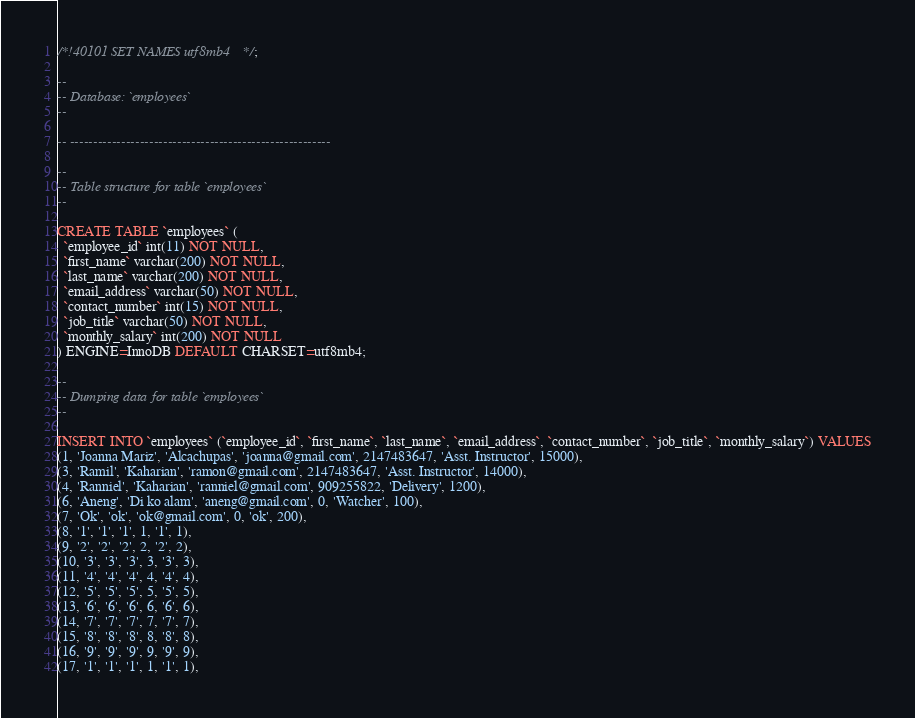Convert code to text. <code><loc_0><loc_0><loc_500><loc_500><_SQL_>/*!40101 SET NAMES utf8mb4 */;

--
-- Database: `employees`
--

-- --------------------------------------------------------

--
-- Table structure for table `employees`
--

CREATE TABLE `employees` (
  `employee_id` int(11) NOT NULL,
  `first_name` varchar(200) NOT NULL,
  `last_name` varchar(200) NOT NULL,
  `email_address` varchar(50) NOT NULL,
  `contact_number` int(15) NOT NULL,
  `job_title` varchar(50) NOT NULL,
  `monthly_salary` int(200) NOT NULL
) ENGINE=InnoDB DEFAULT CHARSET=utf8mb4;

--
-- Dumping data for table `employees`
--

INSERT INTO `employees` (`employee_id`, `first_name`, `last_name`, `email_address`, `contact_number`, `job_title`, `monthly_salary`) VALUES
(1, 'Joanna Mariz', 'Alcachupas', 'joanna@gmail.com', 2147483647, 'Asst. Instructor', 15000),
(3, 'Ramil', 'Kaharian', 'ramon@gmail.com', 2147483647, 'Asst. Instructor', 14000),
(4, 'Ranniel', 'Kaharian', 'ranniel@gmail.com', 909255822, 'Delivery', 1200),
(6, 'Aneng', 'Di ko alam', 'aneng@gmail.com', 0, 'Watcher', 100),
(7, 'Ok', 'ok', 'ok@gmail.com', 0, 'ok', 200),
(8, '1', '1', '1', 1, '1', 1),
(9, '2', '2', '2', 2, '2', 2),
(10, '3', '3', '3', 3, '3', 3),
(11, '4', '4', '4', 4, '4', 4),
(12, '5', '5', '5', 5, '5', 5),
(13, '6', '6', '6', 6, '6', 6),
(14, '7', '7', '7', 7, '7', 7),
(15, '8', '8', '8', 8, '8', 8),
(16, '9', '9', '9', 9, '9', 9),
(17, '1', '1', '1', 1, '1', 1),</code> 